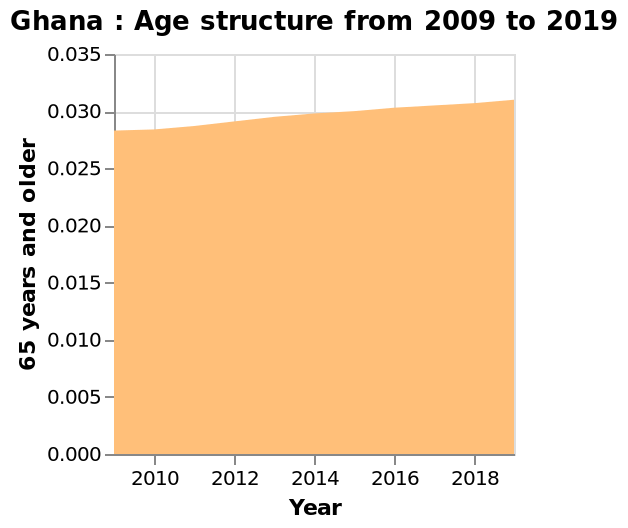<image>
Describe the following image in detail This area plot is named Ghana : Age structure from 2009 to 2019. The x-axis plots Year on linear scale from 2010 to 2018 while the y-axis measures 65 years and older on linear scale from 0.000 to 0.035. What is the time period covered by the area plot? The area plot represents the age structure of Ghana from 2009 to 2019. How would you describe the change in the number of elderly citizens in Ghana? The change in the number of elderly citizens in Ghana can be described as a gradual and consistent increase over the years. Is this line plot named Ghana: Age structure from 2009 to 2019? No.This area plot is named Ghana : Age structure from 2009 to 2019. The x-axis plots Year on linear scale from 2010 to 2018 while the y-axis measures 65 years and older on linear scale from 0.000 to 0.035. 